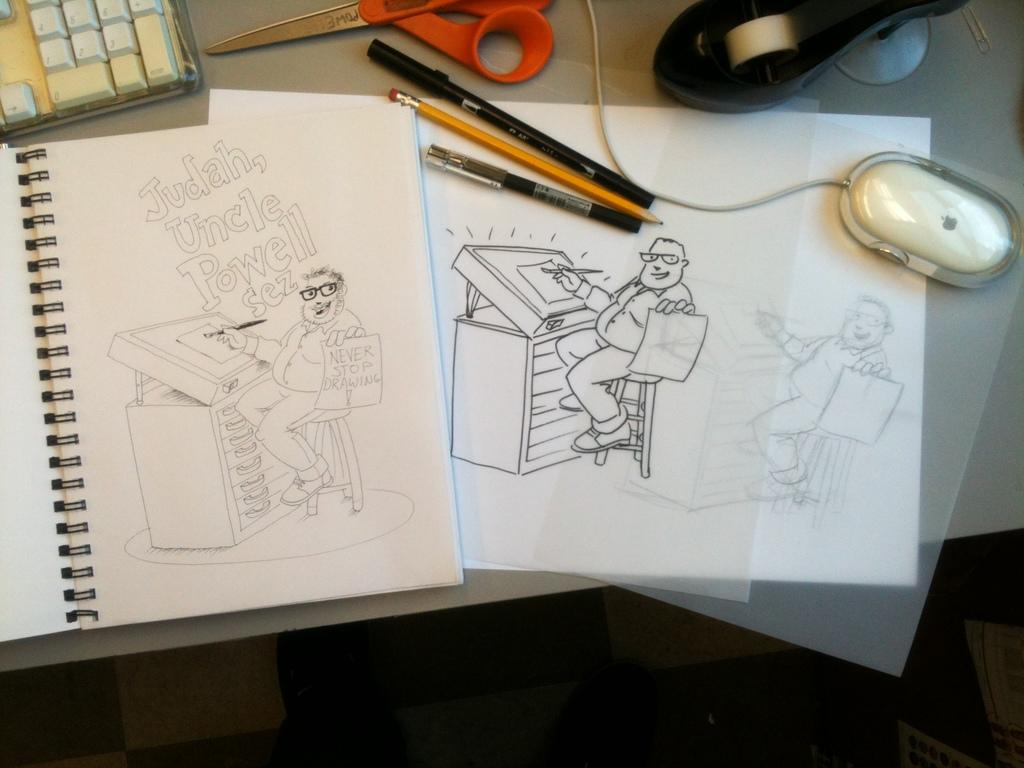What type of object can be seen in the image related to reading? There is a book in the image. What type of object can be seen in the image related to a computer? There is a keyboard and a mouse in the image. What type of writing instruments can be seen in the image? There are pens in the image. What type of cutting tool can be seen in the image? There are scissors in the image. Where are all the objects located in the image? All objects are on a table. What type of reaction can be seen on the calendar in the image? There is no calendar present in the image, and therefore no reaction can be observed. What type of head is visible in the image? There is no head visible in the image; the objects mentioned are a book, keyboard, mouse, pens, and scissors. 